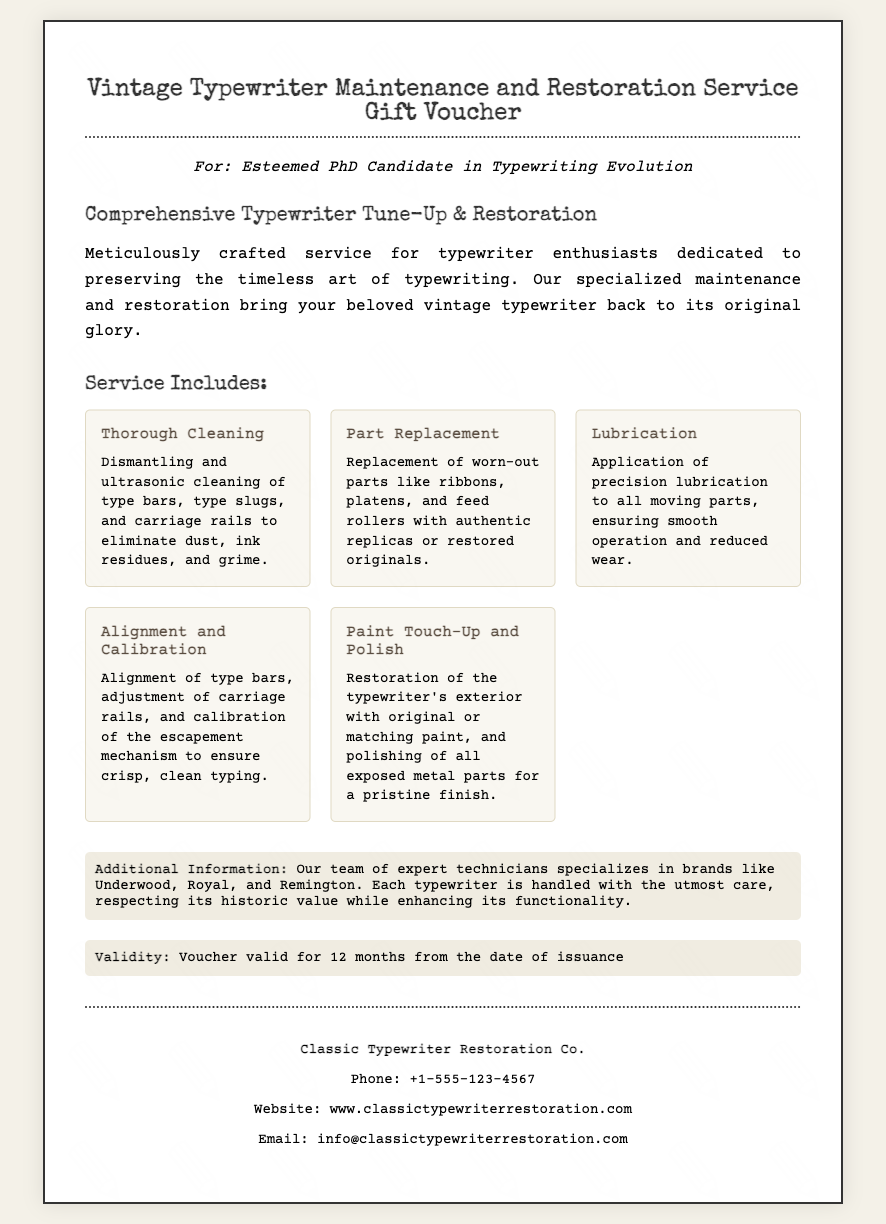What is the title of the voucher? The title of the voucher is mentioned prominently at the top of the document.
Answer: Vintage Typewriter Maintenance and Restoration Service Gift Voucher For whom is the voucher intended? The voucher specifies the recipient in the opening section.
Answer: Esteemed PhD Candidate in Typewriting Evolution How long is the voucher valid? The validity period is indicated in a specific section of the document.
Answer: 12 months What service includes the thorough cleaning? The description of the thorough cleaning service outlines its specific actions.
Answer: Dismantling and ultrasonic cleaning of type bars, type slugs, and carriage rails Which brands does the service team specialize in? The additional information section lists specific brands the technicians focus on.
Answer: Underwood, Royal, and Remington What is the name of the company offering the service? The company's name is displayed at the bottom in the contact details section.
Answer: Classic Typewriter Restoration Co What type of paint service is provided? The service details mention the restoration of the typewriter's exterior.
Answer: Paint Touch-Up How can you contact the service provider? The contact details section outlines methods to reach the company.
Answer: Phone: +1-555-123-4567 